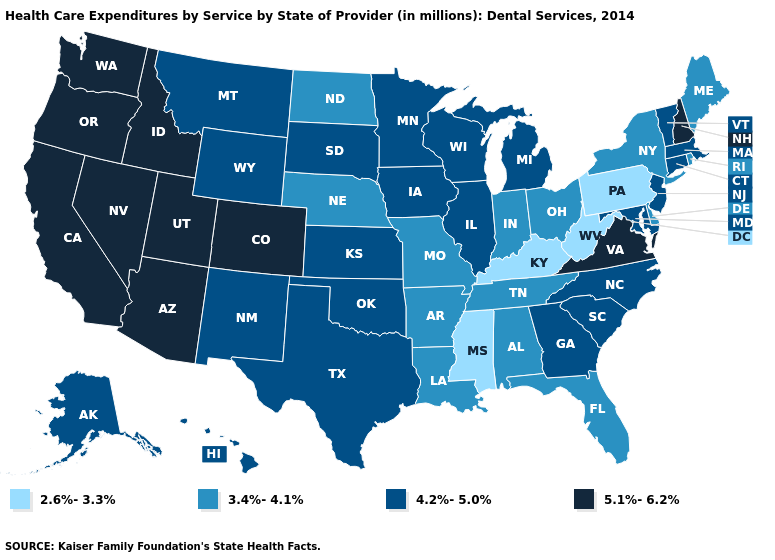What is the value of Vermont?
Short answer required. 4.2%-5.0%. What is the value of Louisiana?
Short answer required. 3.4%-4.1%. Name the states that have a value in the range 4.2%-5.0%?
Concise answer only. Alaska, Connecticut, Georgia, Hawaii, Illinois, Iowa, Kansas, Maryland, Massachusetts, Michigan, Minnesota, Montana, New Jersey, New Mexico, North Carolina, Oklahoma, South Carolina, South Dakota, Texas, Vermont, Wisconsin, Wyoming. What is the value of Louisiana?
Keep it brief. 3.4%-4.1%. Does the first symbol in the legend represent the smallest category?
Give a very brief answer. Yes. Name the states that have a value in the range 3.4%-4.1%?
Short answer required. Alabama, Arkansas, Delaware, Florida, Indiana, Louisiana, Maine, Missouri, Nebraska, New York, North Dakota, Ohio, Rhode Island, Tennessee. Among the states that border Missouri , which have the lowest value?
Write a very short answer. Kentucky. What is the value of Alabama?
Short answer required. 3.4%-4.1%. What is the highest value in the USA?
Concise answer only. 5.1%-6.2%. Name the states that have a value in the range 5.1%-6.2%?
Concise answer only. Arizona, California, Colorado, Idaho, Nevada, New Hampshire, Oregon, Utah, Virginia, Washington. Does the map have missing data?
Give a very brief answer. No. What is the value of Louisiana?
Concise answer only. 3.4%-4.1%. What is the value of Alabama?
Be succinct. 3.4%-4.1%. Among the states that border Oklahoma , which have the highest value?
Short answer required. Colorado. Does Mississippi have the lowest value in the USA?
Quick response, please. Yes. 